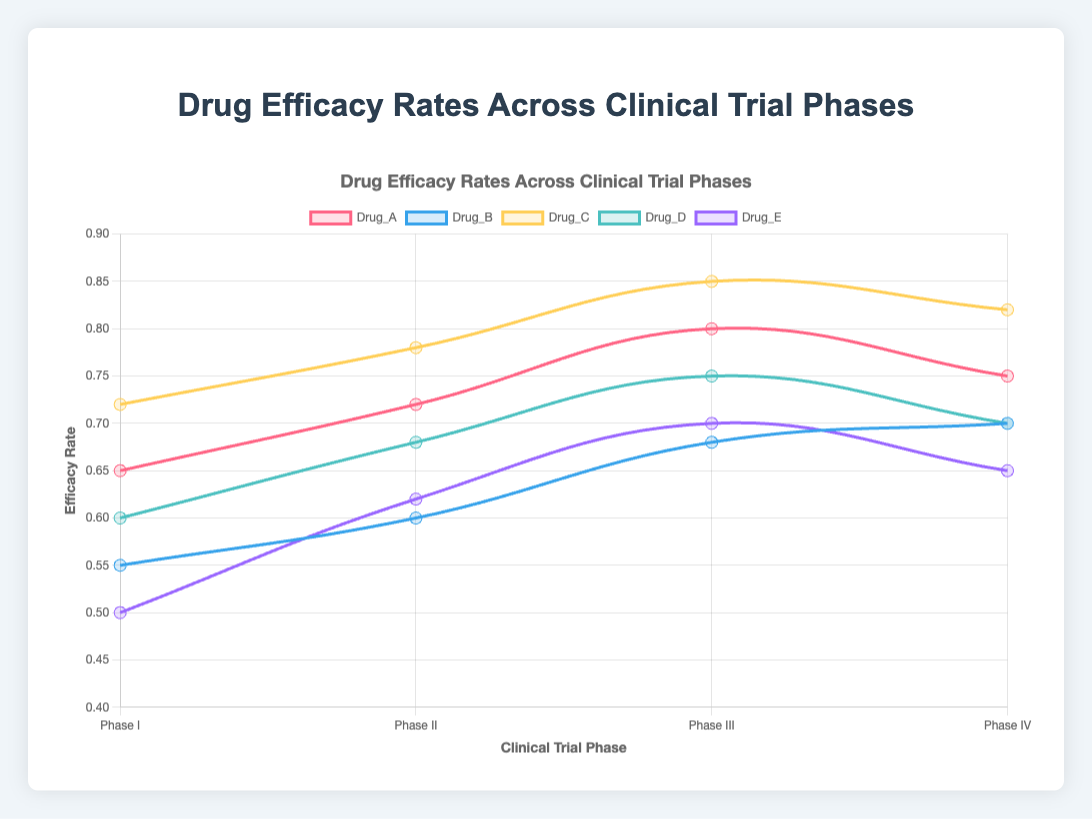Which drug has the highest overall efficacy rate in Phase III? To find the drug with the highest efficacy rate in Phase III, look at the Phase III values for each drug. The efficacy rates for the drugs in Phase III are: Drug_A - 0.80, Drug_B - 0.68, Drug_C - 0.85, Drug_D - 0.75, and Drug_E - 0.70. The highest value is 0.85 for Drug_C.
Answer: Drug_C Which drug shows the greatest decrease in efficacy rate from Phase III to Phase IV? To identify the drug with the largest decrease, subtract the Phase IV rate from the Phase III rate for each drug. The differences are: Drug_A (0.80 - 0.75 = 0.05), Drug_B (0.68 - 0.70 = -0.02), Drug_C (0.85 - 0.82 = 0.03), Drug_D (0.75 - 0.70 = 0.05), and Drug_E (0.70 - 0.65 = 0.05). Three drugs have the greatest decrease of 0.05: Drug_A, Drug_D, and Drug_E.
Answer: Drug_A, Drug_D, Drug_E What is the overall trend in efficacy rates for Drug_B across all phases? To determine the overall trend, observe the progression of efficacy rates across all phases for Drug_B: Phase I - 0.55, Phase II - 0.60, Phase III - 0.68, Phase IV - 0.70. The efficacy rates show a consistent increase from Phase I to Phase IV.
Answer: Increasing Which drugs have an efficacy rate in Phase I that is higher than the efficacy rate of Drug_B in Phase III? First, identify Drug_B's efficacy rate in Phase III, which is 0.68. Then, compare this with the Phase I rates of each drug: Drug_A - 0.65, Drug_B - 0.55, Drug_C - 0.72, Drug_D - 0.60, Drug_E - 0.50. Only Drug_C has an efficacy rate in Phase I (0.72) greater than 0.68.
Answer: Drug_C If the average efficacy rate across all phases for Drug_D is calculated, what is this average rate? Compute the average efficacy rate by summing the rates across all phases for Drug_D and dividing by the number of phases. The rates are: 0.60 (Phase I), 0.68 (Phase II), 0.75 (Phase III), and 0.70 (Phase IV). Sum = 0.60 + 0.68 + 0.75 + 0.70 = 2.73. The average is 2.73 / 4 = 0.6825.
Answer: 0.6825 